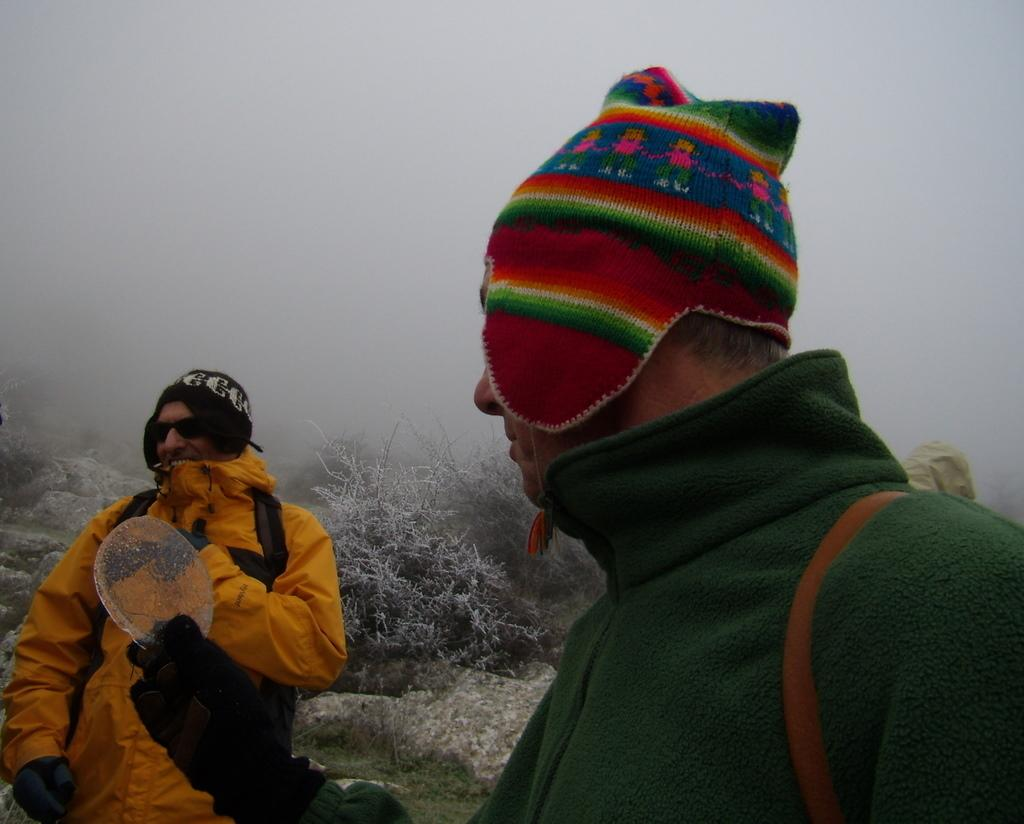How many persons are wearing monkey caps in the image? There are two persons with monkey caps in the image. What is one of the persons holding in the image? There is a person holding a piece of ice in the image. What type of vegetation can be seen in the image? There are plants in the image. What is visible in the background of the image? There is fog in the background of the image. What theory is being taught by the person holding the piece of ice in the image? There is no indication in the image that a theory is being taught, and the person is simply holding a piece of ice. 